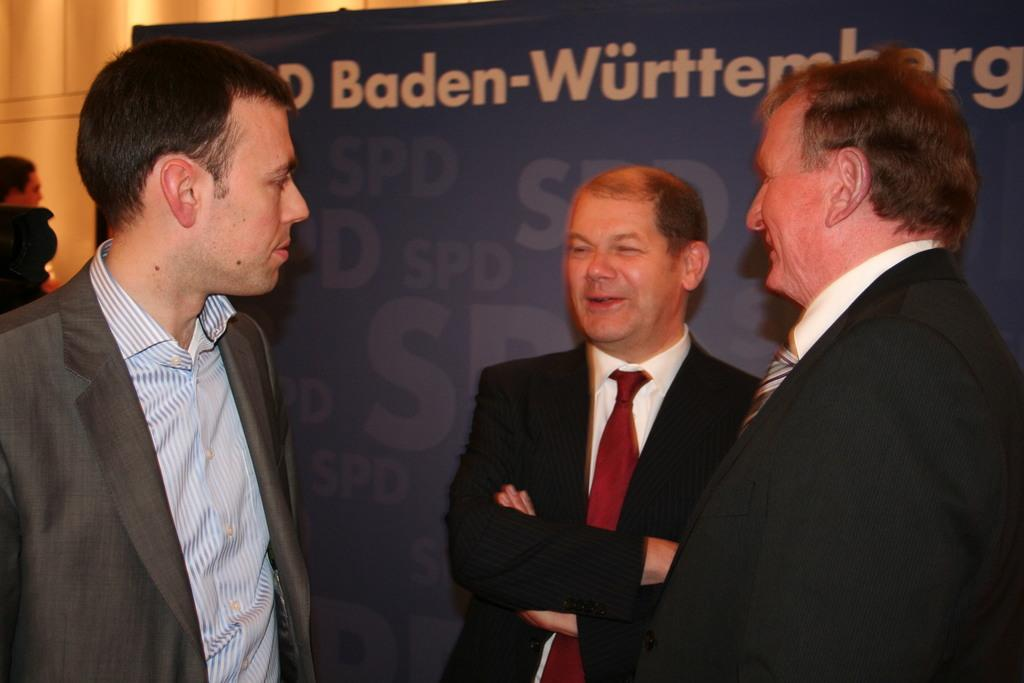How many people are in the group visible in the image? There is a group of people in the image, but the exact number is not specified. What are the people in the group doing in the image? The group of people is standing in the image. What can be seen in the background of the image? The provided facts do not mention anything about the background of the image. What type of joke is the aunt telling in the image? There is no aunt or joke present in the image. How is the group of people measuring the distance between them in the image? There is no indication in the image that the group of people is measuring anything, including the distance between them. 